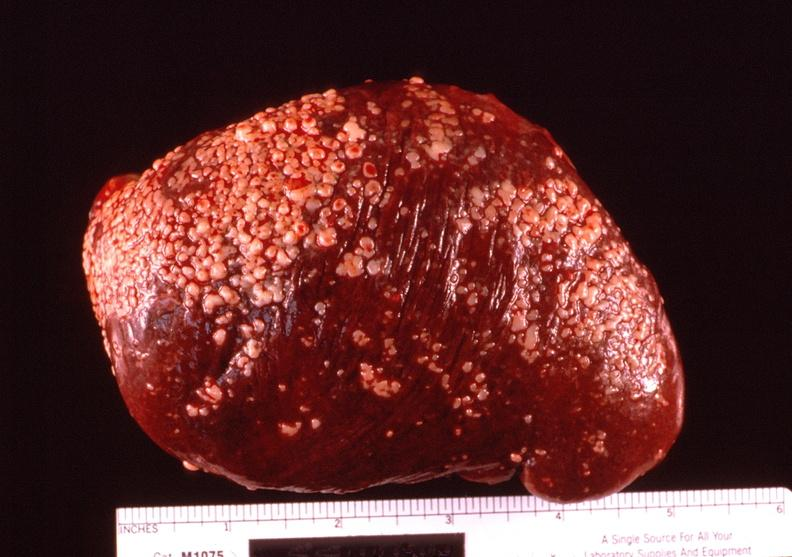does this image show spleen, hyaline perisplenitis associated with ascites?
Answer the question using a single word or phrase. Yes 